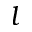<formula> <loc_0><loc_0><loc_500><loc_500>l</formula> 